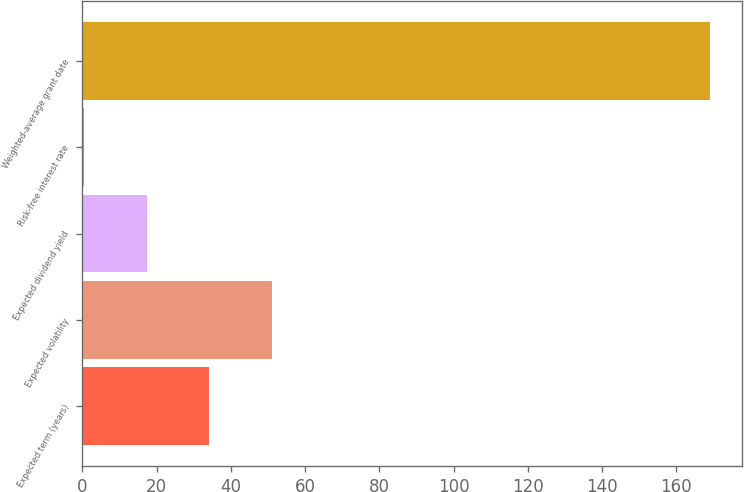Convert chart. <chart><loc_0><loc_0><loc_500><loc_500><bar_chart><fcel>Expected term (years)<fcel>Expected volatility<fcel>Expected dividend yield<fcel>Risk-free interest rate<fcel>Weighted-average grant date<nl><fcel>34.14<fcel>51.01<fcel>17.27<fcel>0.4<fcel>169.14<nl></chart> 